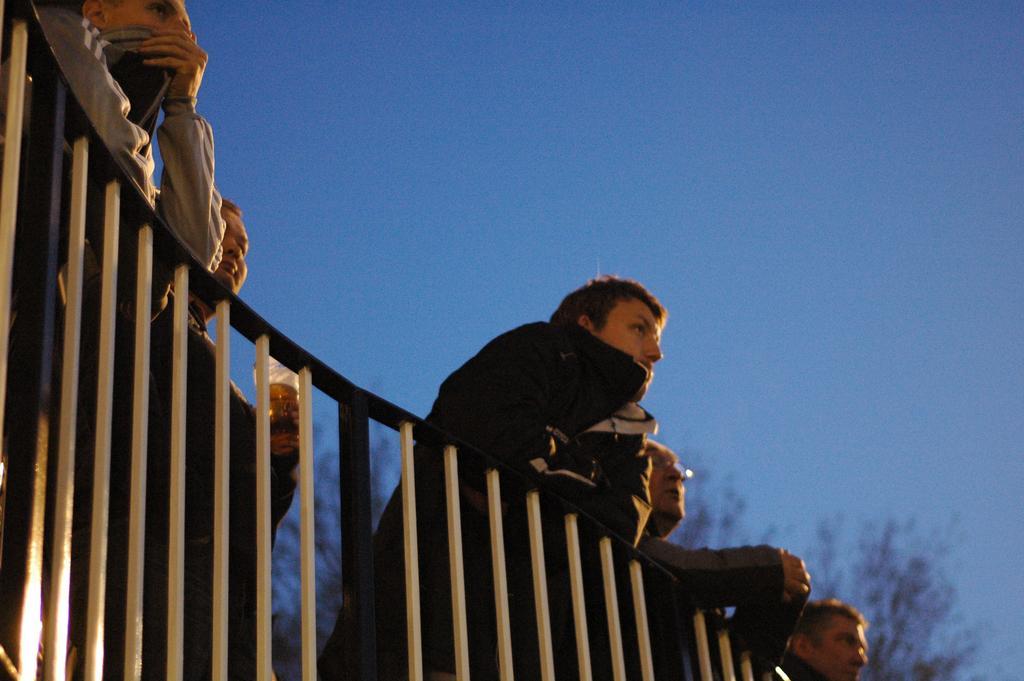In one or two sentences, can you explain what this image depicts? This image is taken outdoors. At the top of the image there is a sky. In the background there are a few trees. At the bottom of the image there is a railing. In the middle of the image a few people are standing behind the railing. 